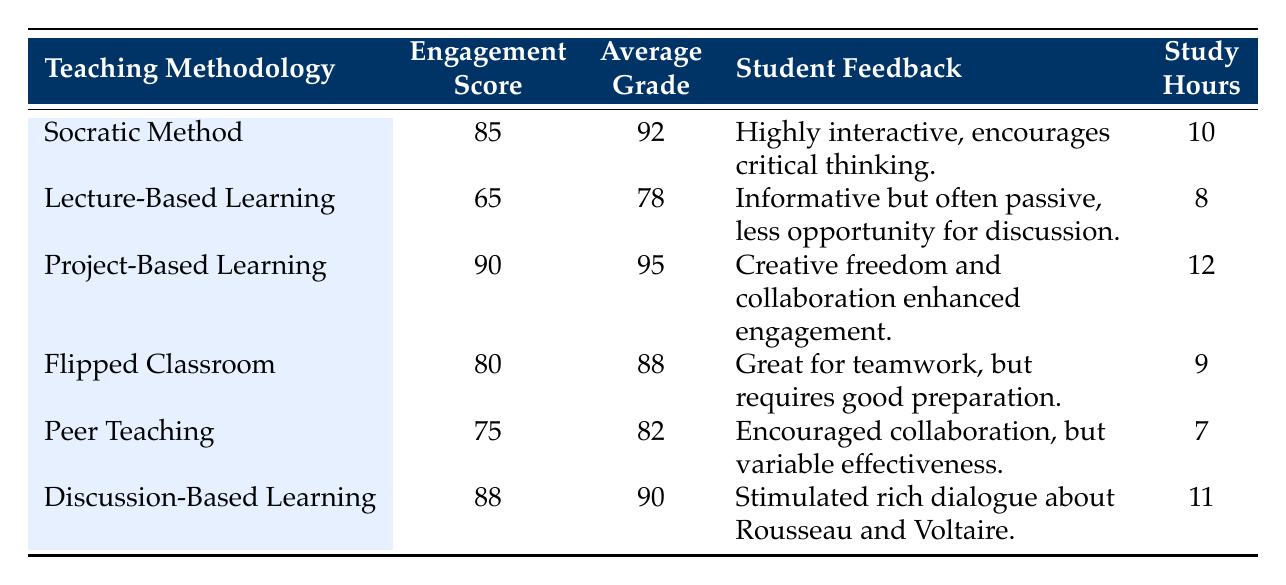What is the student engagement score for the Project-Based Learning methodology? The table lists the student engagement scores for each teaching methodology, and for Project-Based Learning, the score is explicitly noted as 90.
Answer: 90 Which teaching methodology has the highest average grade? By reviewing the average grades in the table, Project-Based Learning has the highest average grade of 95 compared to other methodologies.
Answer: Project-Based Learning Is the feedback for Flipped Classroom positive? The feedback for Flipped Classroom states, "Great for teamwork, but requires good preparation." This indicates a generally positive view, though it acknowledges some challenges.
Answer: Yes What is the difference in student engagement scores between Socratic Method and Discussion-Based Learning? The student engagement score for Socratic Method is 85, while for Discussion-Based Learning it is 88. The difference is calculated by subtracting 85 from 88, giving a result of 3.
Answer: 3 What is the average study time for all methodologies? The total study hours for all methodologies are 10 + 8 + 12 + 9 + 7 + 11 = 57. Since there are 6 methodologies, the average study time is 57 divided by 6, which results in 9.5.
Answer: 9.5 Does Peer Teaching have a higher engagement score than Lecture-Based Learning? Peer Teaching's engagement score is 75 and Lecture-Based Learning's score is 65. Since 75 is greater than 65, the answer is affirmative.
Answer: Yes Which methodology received feedback emphasizing critical thinking? The feedback for Socratic Method highlights that it is "Highly interactive, encourages critical thinking," specifically noting the emphasis on critical thinking.
Answer: Socratic Method Among the methodologies, which had the lowest student engagement score? By analyzing the engagement scores, Lecture-Based Learning has the lowest score at 65 compared to all other methodologies listed.
Answer: Lecture-Based Learning 